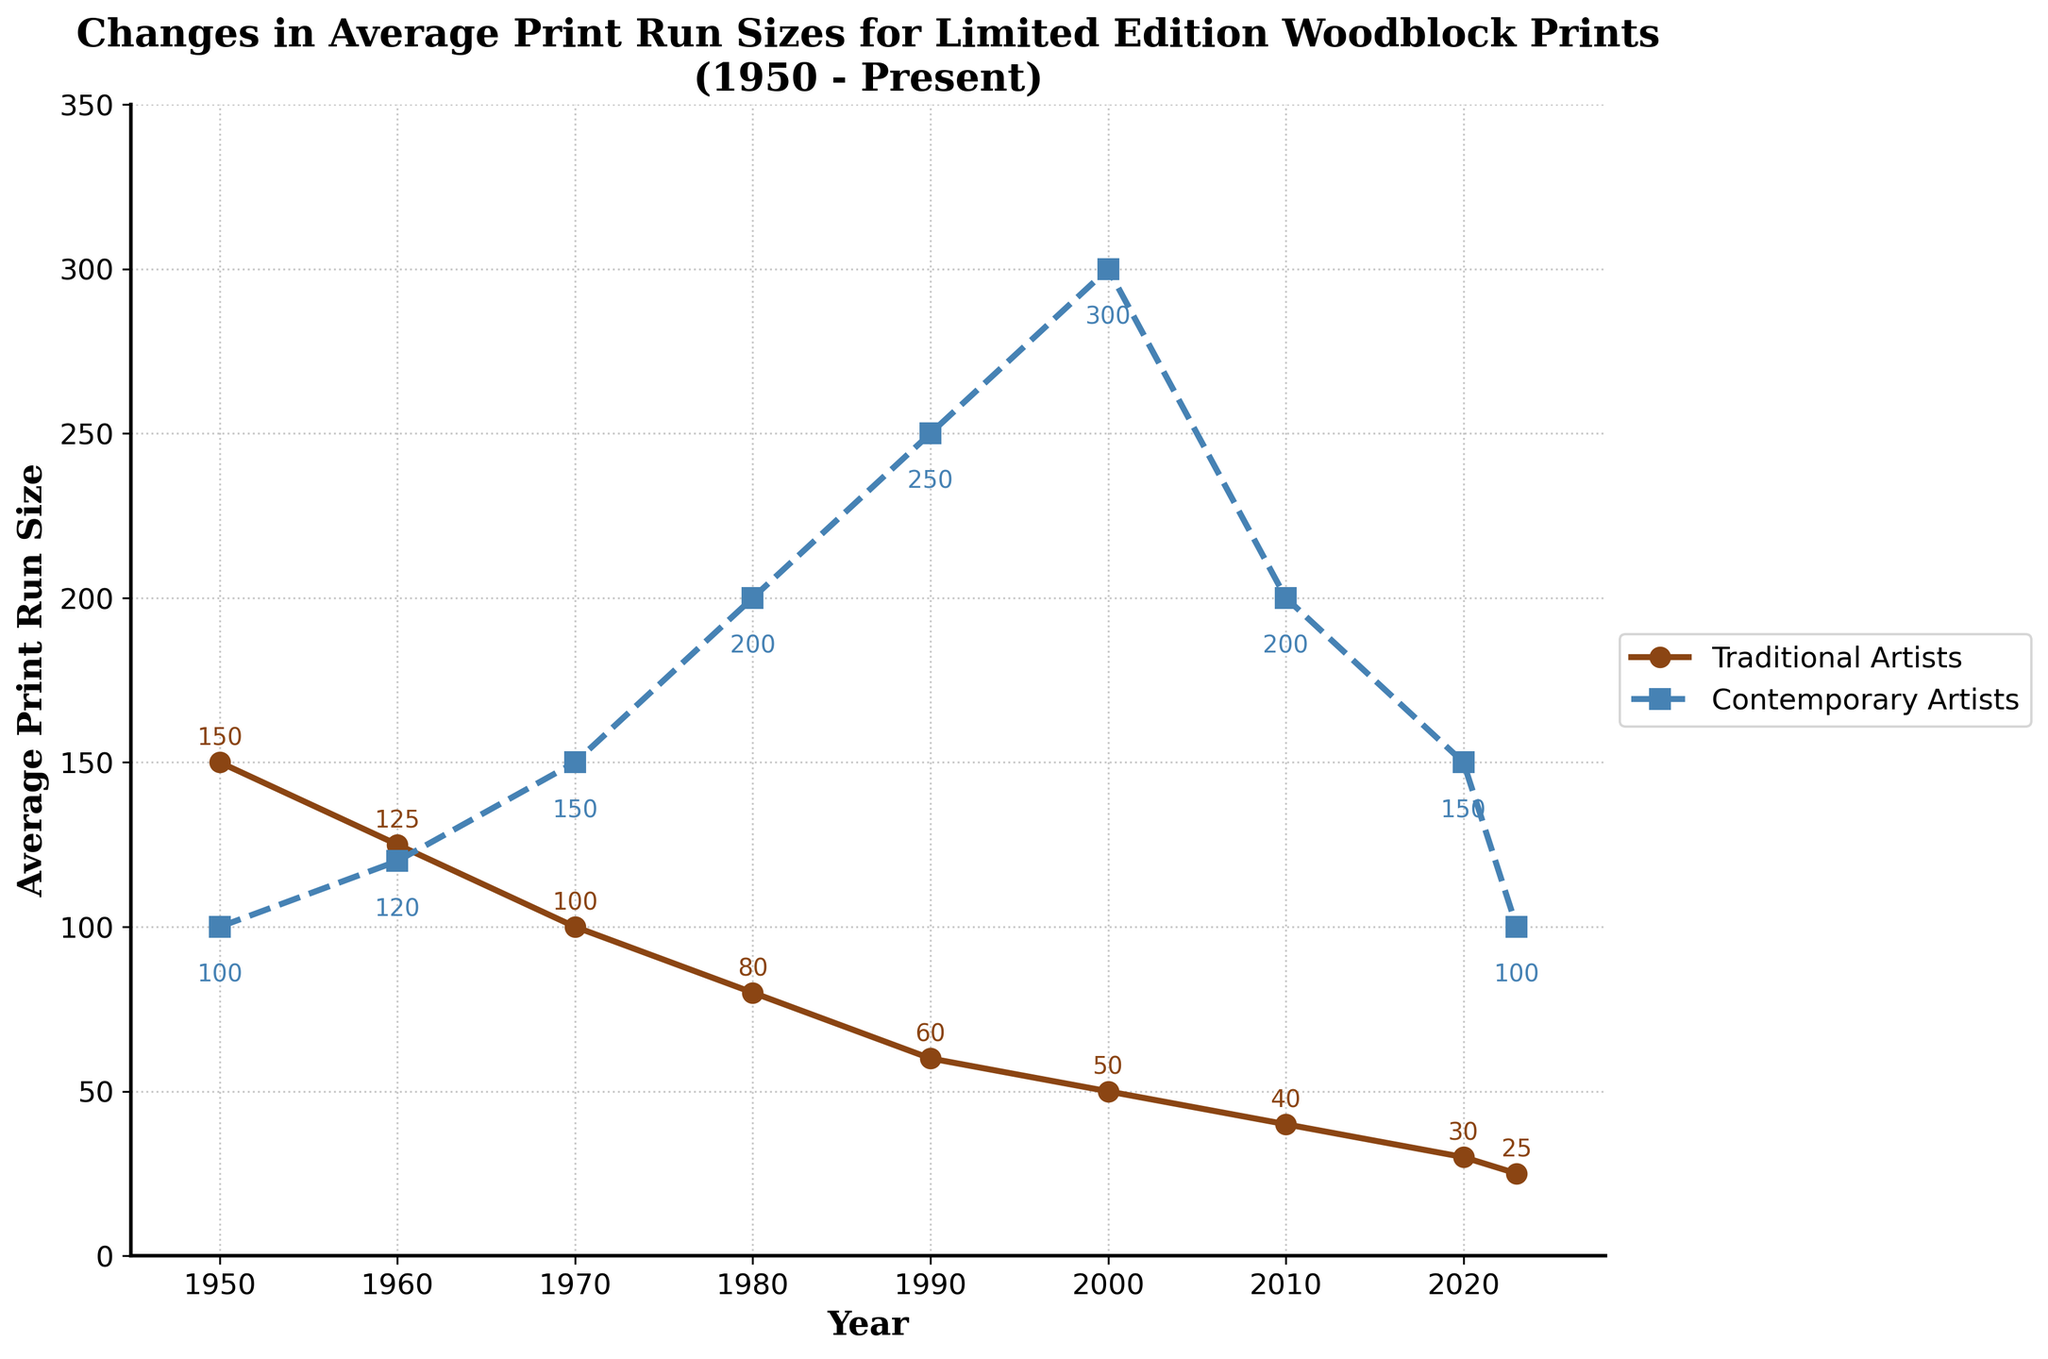What's the trend in average print run size for traditional artists from 1950 to present? The average print run size for traditional artists decreases steadily from 150 in 1950 to 25 in 2023. Track the downward slope from each data point in the chart to deduce this trend.
Answer: Decreasing In which year did the average print run size for contemporary artists peak? Look for the highest point on the plot line for contemporary artists. The highest point is at 300 in the year 2000.
Answer: 2000 By how much did the average print run size for traditional artists decrease between 1950 and 2023? Subtract the print run size for traditional artists in 2023 from that of 1950: 150 - 25 = 125.
Answer: 125 Are there any years where the average print run size for traditional and contemporary artists are the same? Observe if the two plot lines intersect at any point. They do not intersect at any data points.
Answer: No How does the average print run size for contemporary artists in 2023 compare to that in 1950? Compare the two values directly from the chart. In 1950, it was 100, and in 2023, it is 100.
Answer: Same What is the combined average print run size for both traditional and contemporary artists in 1990? Add the values for traditional and contemporary artists in 1990: 60 + 250 = 310.
Answer: 310 During which decade did contemporary artists experience the most significant increase in average print run size? Examine the slope of the line for contemporary artists. The steepest increase is between 1990 and 2000, where it goes from 250 to 300.
Answer: 1990s What is the minimum average print run size observed for traditional artists in the dataset? Identify the smallest value on the plot line for traditional artists, which is 25 in 2023.
Answer: 25 Which artist type had a higher average print run size in 2010, and by how much? Compare the values for traditional (40) and contemporary (200) in 2010. Contemporary artists had a higher print run size by (200 - 40) = 160.
Answer: Contemporary, 160 Between 2000 and 2020, what was the percentage decrease in the average print run size for contemporary artists? Calculate the decrease as follows: (300 - 150) / 300 * 100 = 50%.
Answer: 50% 